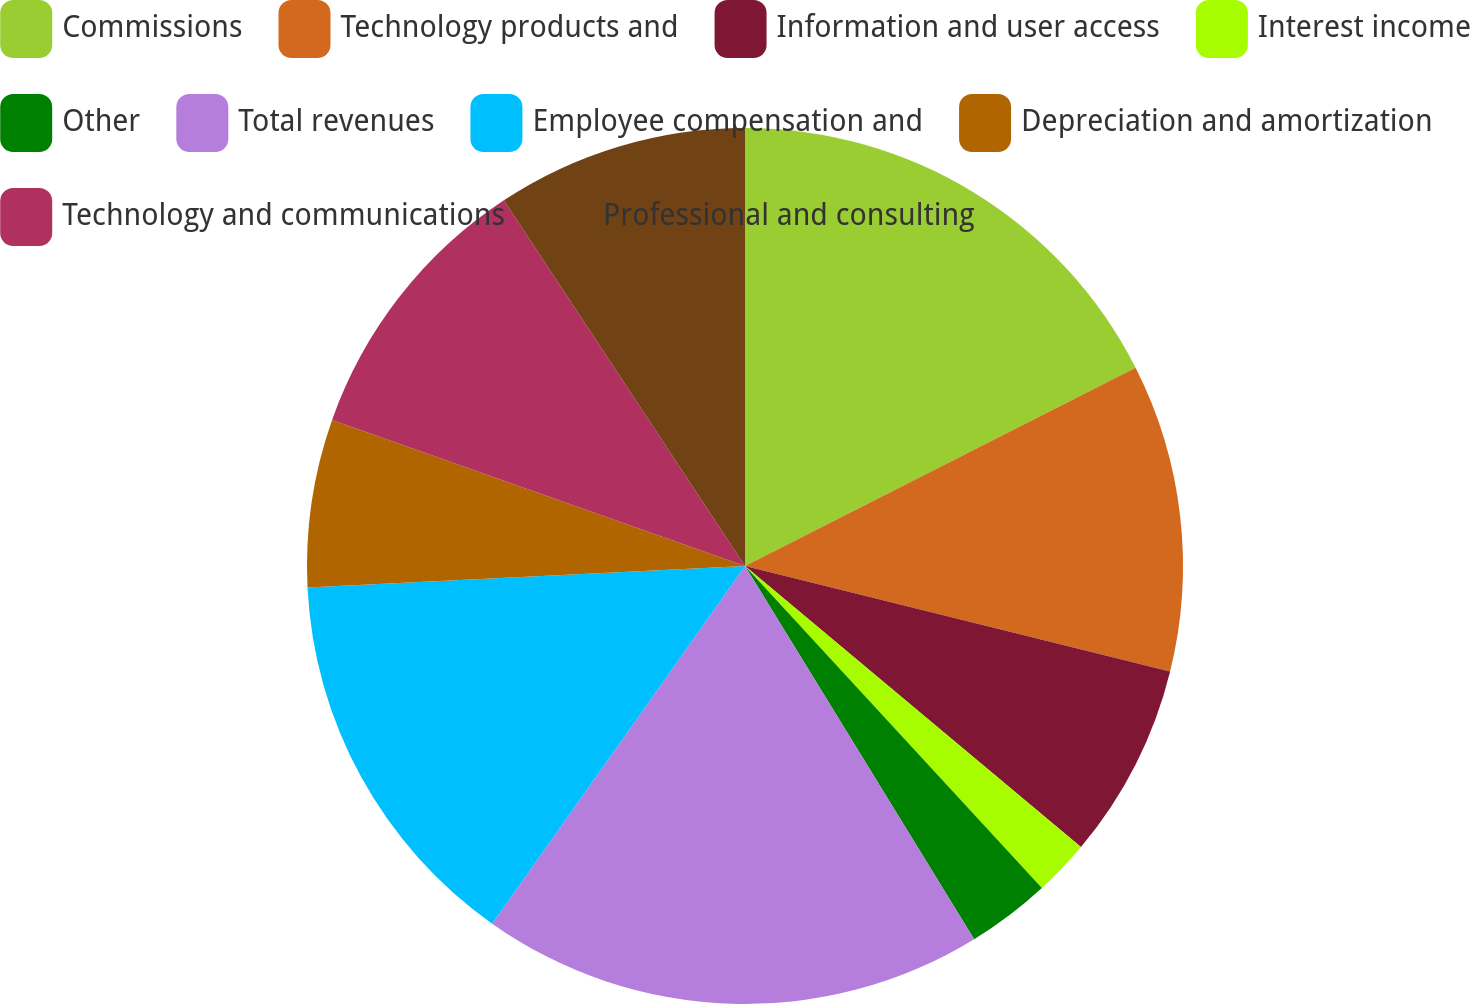Convert chart to OTSL. <chart><loc_0><loc_0><loc_500><loc_500><pie_chart><fcel>Commissions<fcel>Technology products and<fcel>Information and user access<fcel>Interest income<fcel>Other<fcel>Total revenues<fcel>Employee compensation and<fcel>Depreciation and amortization<fcel>Technology and communications<fcel>Professional and consulting<nl><fcel>17.53%<fcel>11.34%<fcel>7.22%<fcel>2.06%<fcel>3.09%<fcel>18.56%<fcel>14.43%<fcel>6.19%<fcel>10.31%<fcel>9.28%<nl></chart> 